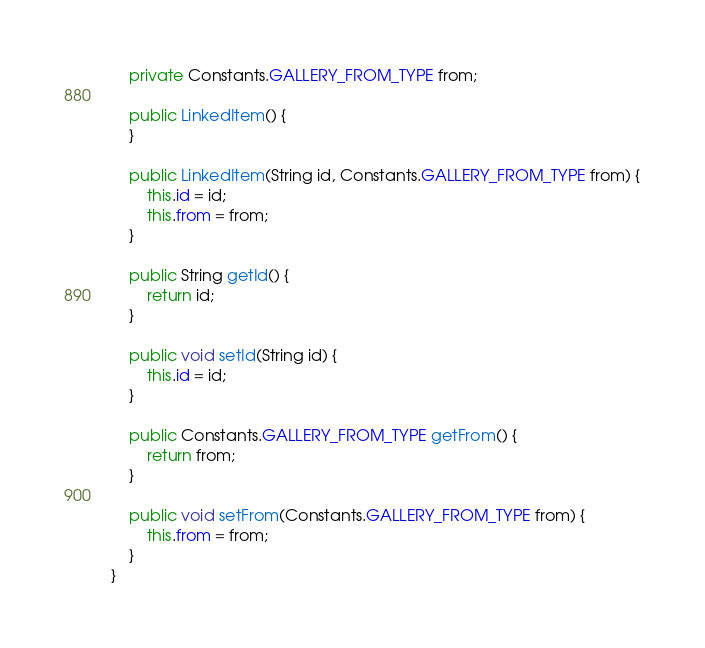<code> <loc_0><loc_0><loc_500><loc_500><_Java_>    private Constants.GALLERY_FROM_TYPE from;

    public LinkedItem() {
    }

    public LinkedItem(String id, Constants.GALLERY_FROM_TYPE from) {
        this.id = id;
        this.from = from;
    }

    public String getId() {
        return id;
    }

    public void setId(String id) {
        this.id = id;
    }

    public Constants.GALLERY_FROM_TYPE getFrom() {
        return from;
    }

    public void setFrom(Constants.GALLERY_FROM_TYPE from) {
        this.from = from;
    }
}
</code> 